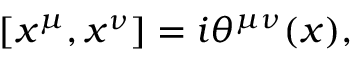Convert formula to latex. <formula><loc_0><loc_0><loc_500><loc_500>[ x ^ { \mu } , x ^ { \nu } ] = i \theta ^ { \mu \nu } ( x ) ,</formula> 